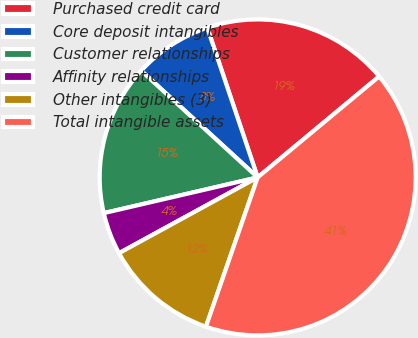Convert chart to OTSL. <chart><loc_0><loc_0><loc_500><loc_500><pie_chart><fcel>Purchased credit card<fcel>Core deposit intangibles<fcel>Customer relationships<fcel>Affinity relationships<fcel>Other intangibles (3)<fcel>Total intangible assets<nl><fcel>19.13%<fcel>8.03%<fcel>15.43%<fcel>4.33%<fcel>11.73%<fcel>41.34%<nl></chart> 